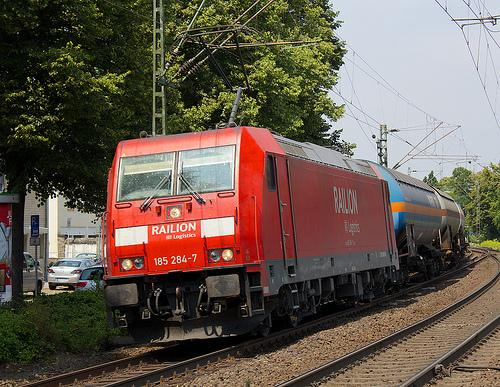Explain the position of the tank car in relation to the red train engine. The tank car is behind the red train engine, and they are both on the train tracks. As a poet, express the scene of the image with a main focus on the train. and clouds covering the overcast sky. Describe the overall atmosphere of the image, focusing on the weather conditions. The image has an overcast atmosphere with white clouds scattered across the blue sky, suggesting cloudy weather conditions. Consider the entire image, if you were to describe it to a friend in one sentence, what would you say? The picture shows a red train engine with a tank car behind it, both on tracks surrounded by trees, bushes, powerlines, and an overcast sky with white clouds. Count the number of train cars and give a brief description of their appearances. There are 3 train cars: a red train engine, a blue and yellow train car, and a silver tank car. Identify the object in the bottom right corner of the image and describe its appearance. The object is a white plastic carton, appearing in the bottom right corner of the image with dimensions of 224 by 224. Provide a succinct description of the environment surrounding the red train engine. The red train engine is surrounded by train tracks, trees, bushes, powerlines, and an overcast sky with white clouds appearing. Examine the red train engine closely and provide a comprehensive list of its notable features. The red train engine features a lit front headlight, a clear windshield, steps on the side, and is connected to electricity for power. Analyze the image and provide a sentiment associated with the scene. The image evokes a feeling of peacefulness and calm as the train moves slowly along the tracks, surrounded by the stillness of nature and the overcast sky. 